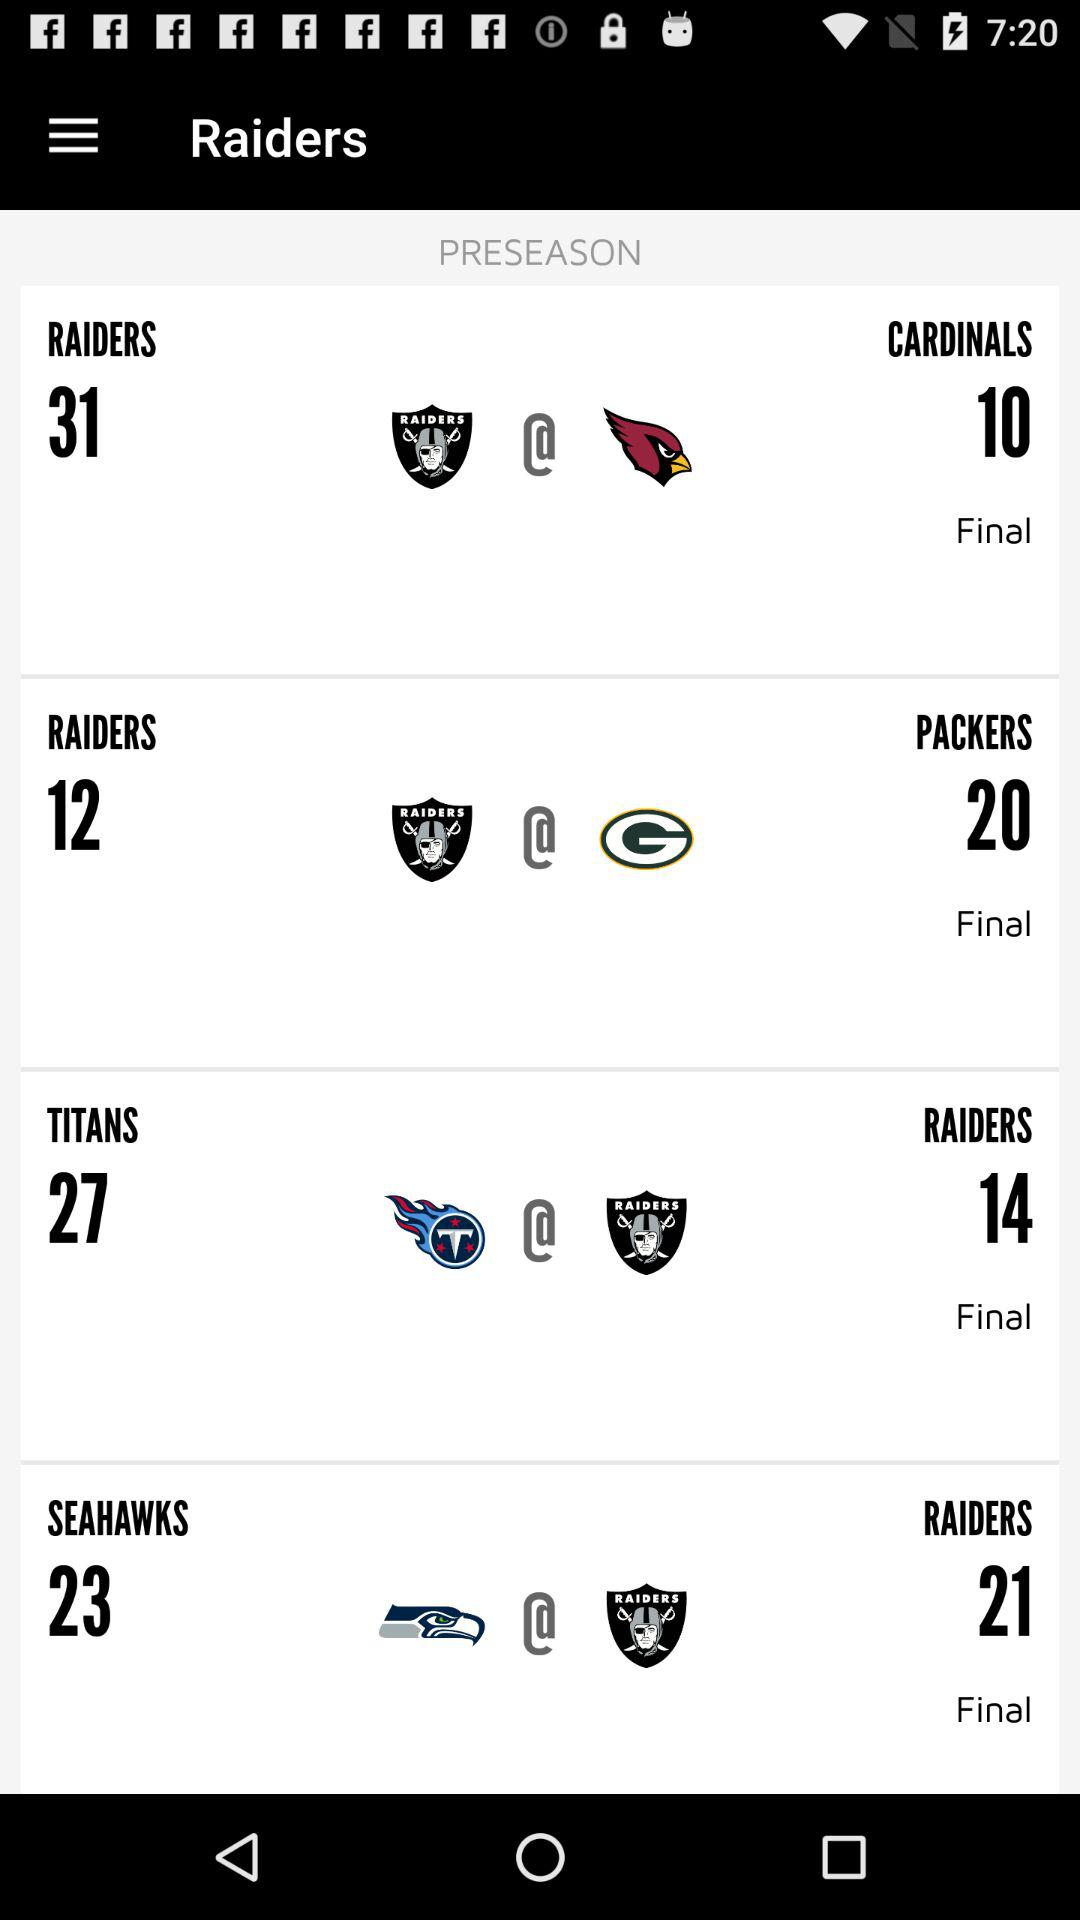How many more points did the Raiders score than the Seahawks?
Answer the question using a single word or phrase. 2 